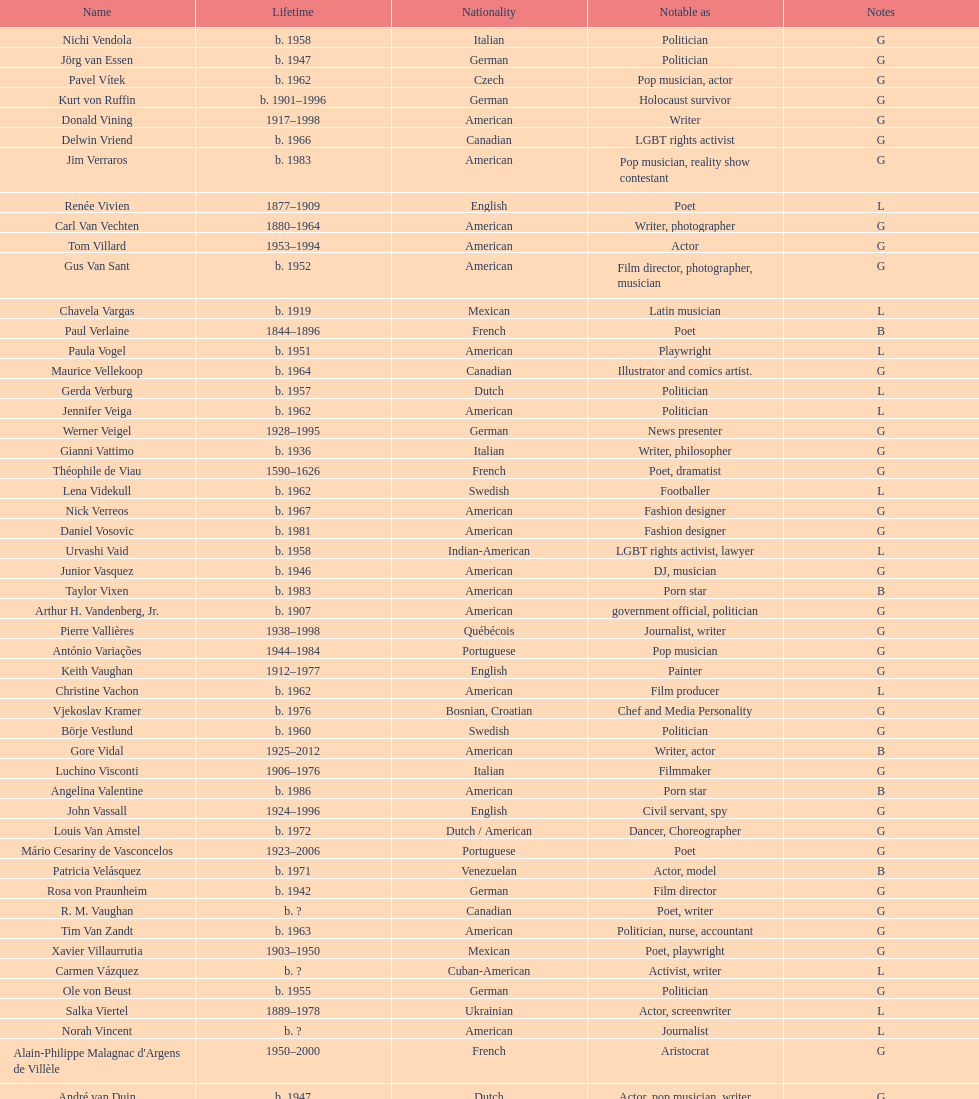Who was canadian, van amstel or valiquette? Valiquette. 